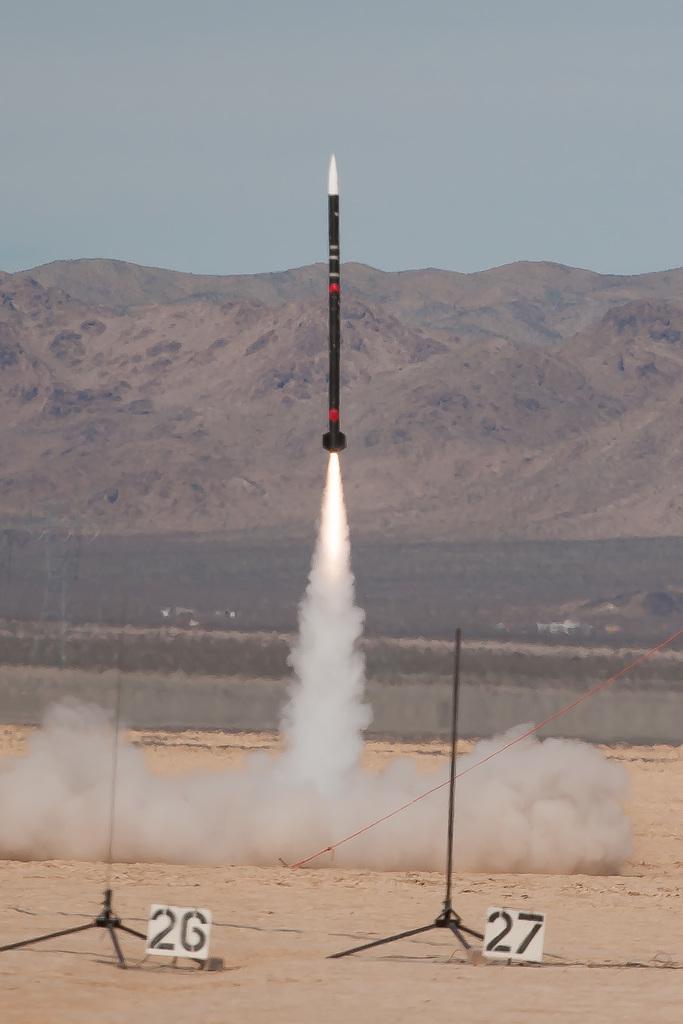In one or two sentences, can you explain what this image depicts? There is a satellite. Here we can see smoke and boards. In the background we can see a mountain and sky. 